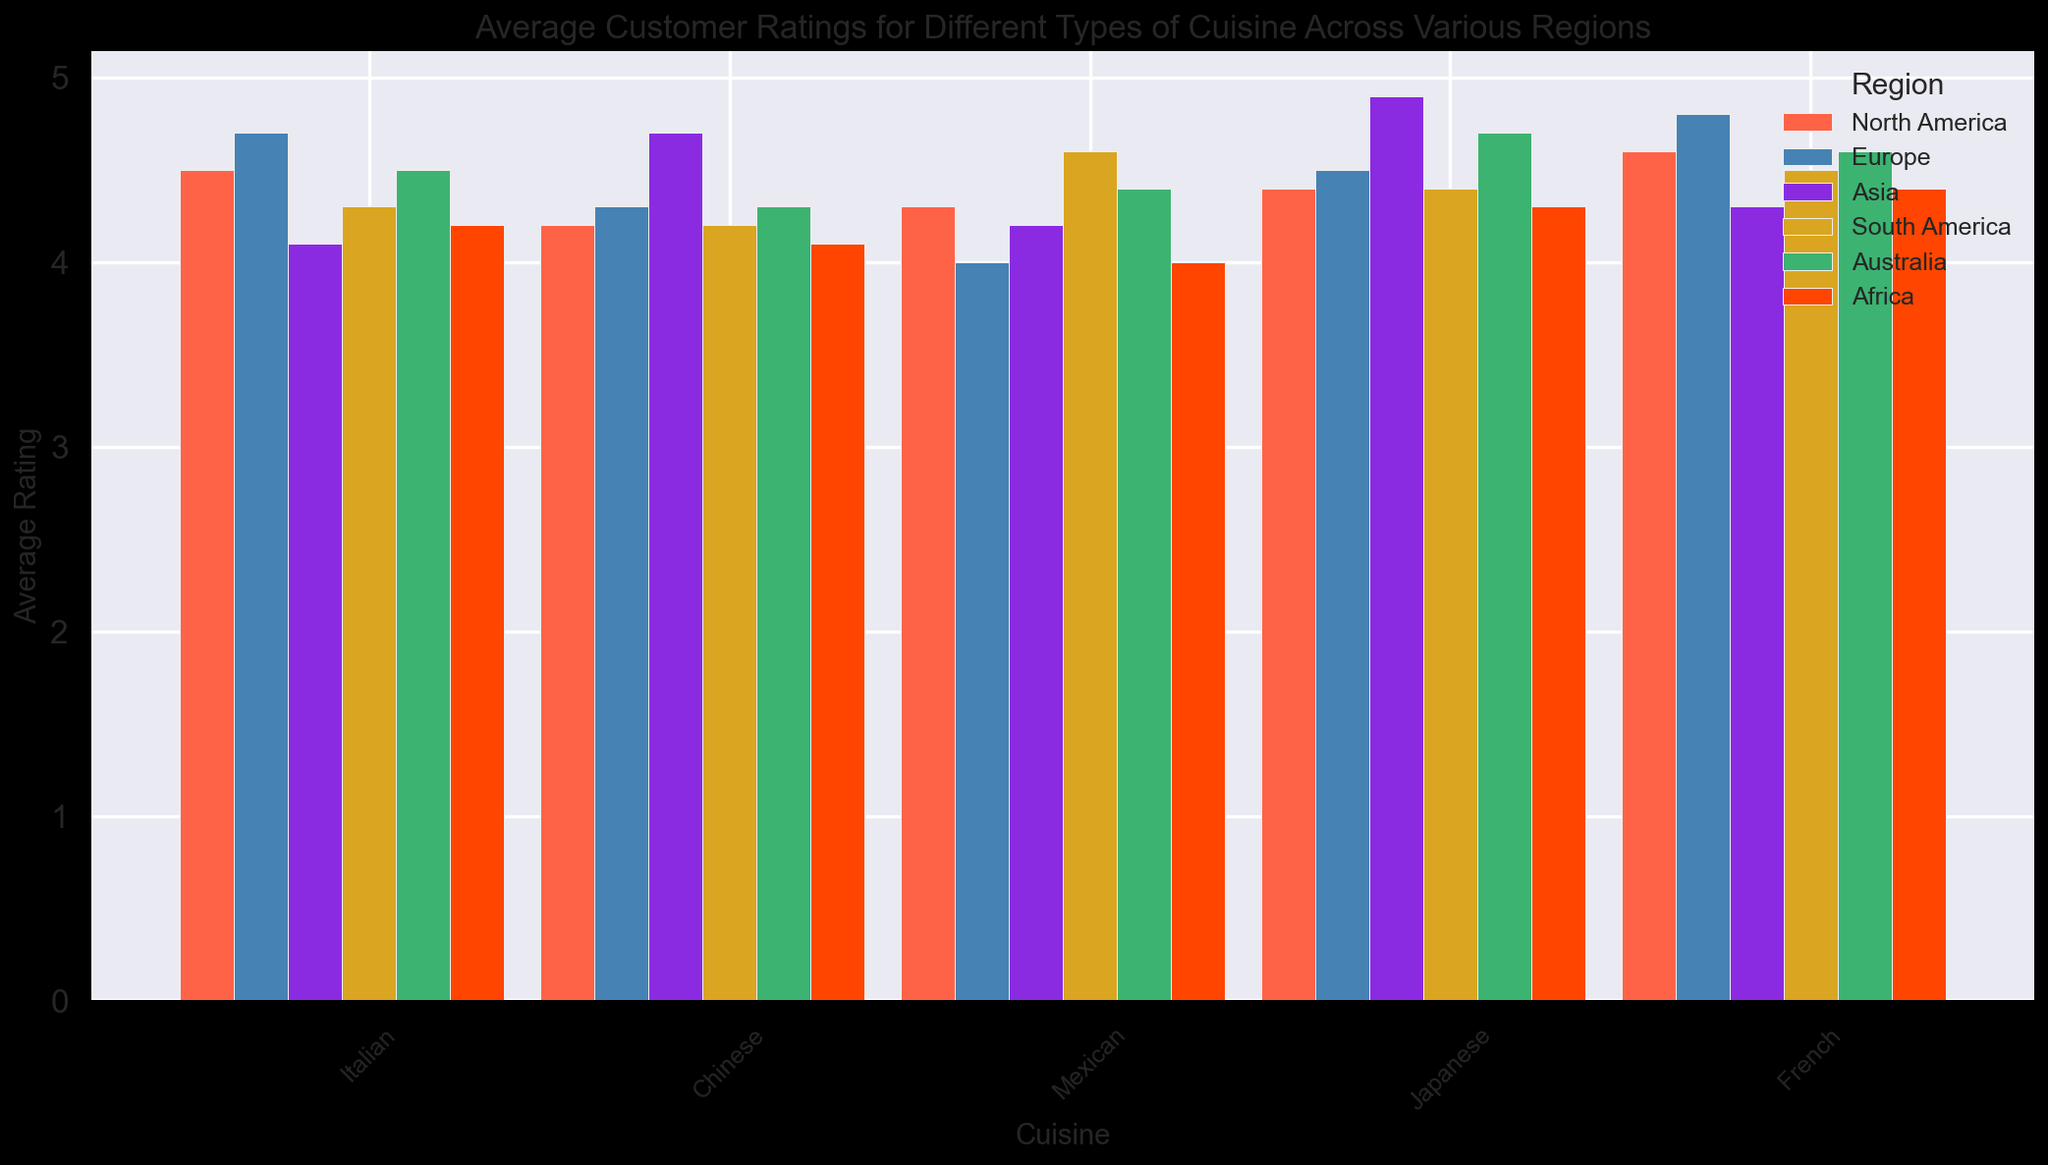Which region has the highest average rating for Japanese cuisine? First, identify the ratings for Japanese cuisine across all regions. North America has 4.4, Europe has 4.5, Asia has 4.9, South America has 4.4, Australia has 4.7, and Africa has 4.3. The highest among these is 4.9 which is in Asia.
Answer: Asia Which region has the lowest average rating for Mexican cuisine? Check the ratings for Mexican cuisine across all regions. North America has 4.3, Europe has 4.0, Asia has 4.2, South America has 4.6, Australia has 4.4, and Africa has 4.0. The lowest rating here is 4.0, which is in Europe and Africa.
Answer: Europe and Africa What is the average rating of Chinese cuisine across all regions? Sum the ratings for Chinese cuisine and divide by the number of regions. The ratings are: North America (4.2), Europe (4.3), Asia (4.7), South America (4.2), Australia (4.3), and Africa (4.1). The sum is 25.8 and there are 6 regions. So, the average is 25.8/6 = 4.3
Answer: 4.3 Which cuisine has the highest overall rating in Europe? Compare the ratings for each cuisine in Europe. The ratings are: Italian (4.7), Chinese (4.3), Mexican (4.0), Japanese (4.5), and French (4.8). The highest rating is 4.8 for French cuisine.
Answer: French Compare the average ratings of French cuisine in North America and Asia. Which one is higher and by how much? North America's rating for French cuisine is 4.6, and Asia's rating is 4.3. Subtract Asia's rating from North America's rating: 4.6 - 4.3 = 0.3. The rating in North America is higher by 0.3.
Answer: North America by 0.3 In which region does Italian cuisine have the lowest average rating, and what is it? Identify the ratings for Italian cuisine in all regions. They include: North America (4.5), Europe (4.7), Asia (4.1), South America (4.3), Australia (4.5), and Africa (4.2). The lowest rating is 4.1 in Asia.
Answer: Asia, 4.1 Is the average rating for Japanese cuisine higher in Australia or South America? Compare the ratings for Japanese cuisine in Australia and South America. Australia has 4.7 and South America has 4.4. Australia is higher.
Answer: Australia Which region has the most consistent average ratings (i.e., the smallest range) across all types of cuisine? Calculate the range for each region (the difference between the highest and lowest average ratings). 
- North America: 4.6 - 4.2 = 0.4
- Europe: 4.8 - 4.0 = 0.8 
- Asia: 4.9 - 4.1 = 0.8 
- South America: 4.6 - 4.2 = 0.4
- Australia: 4.7 - 4.3 = 0.4
- Africa: 4.4 - 4.0 = 0.4 
There are ties between North America, South America, Australia, and Africa.
Answer: North America, South America, Australia, Africa Which cuisine has the smallest variation in average ratings across all regions? Examine the ratings for each cuisine and find the range for each.
- Italian: 4.7 - 4.1 = 0.6
- Chinese: 4.7 - 4.1 = 0.6
- Mexican: 4.6 - 4.0 = 0.6
- Japanese: 4.9 - 4.3 = 0.6
- French: 4.8 - 4.3 = 0.5 
French cuisine has the smallest variation.
Answer: French 